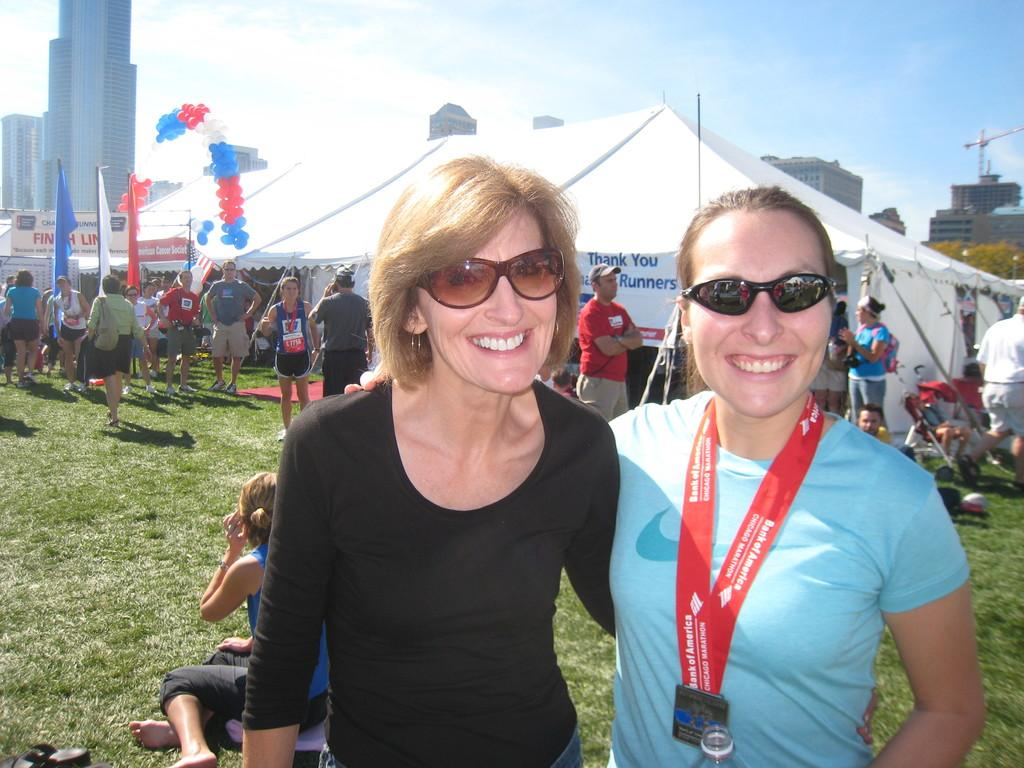How many women are in the image? There are two women in the image. What expression do the women have? The women are smiling. What type of terrain is visible in the image? There is grass visible in the image. Can you describe the people in the image? There are people in the image, including the two women. What type of temporary shelter is present in the image? Tents are present in the image. What decorative items can be seen in the image? Balloons and flags are visible in the image. What type of vegetation is present in the image? Trees are present in the image. What type of structures are visible in the image? There are buildings in the image. What is visible in the background of the image? The sky is visible in the background of the image. How many icicles can be seen hanging from the trees in the image? There are no icicles present in the image, as it is not a winter scene and the trees do not have any icicles hanging from them. 